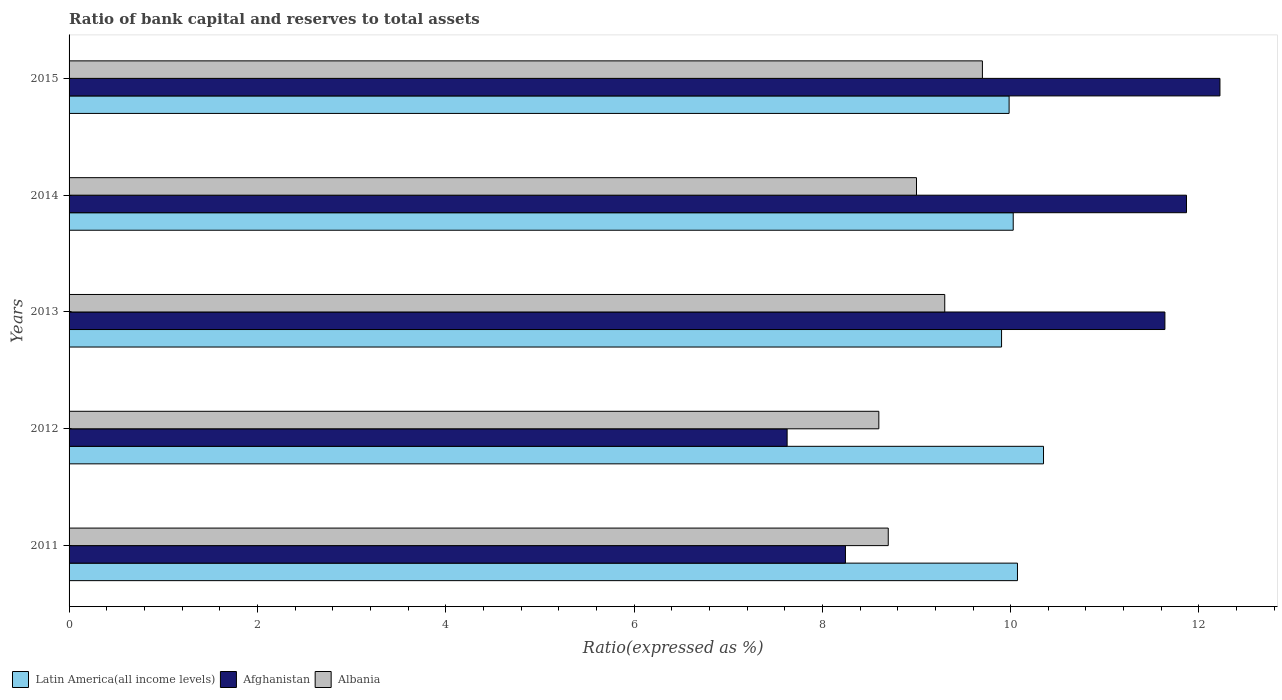How many different coloured bars are there?
Your answer should be very brief. 3. Are the number of bars on each tick of the Y-axis equal?
Ensure brevity in your answer.  Yes. How many bars are there on the 4th tick from the bottom?
Provide a succinct answer. 3. What is the label of the 1st group of bars from the top?
Give a very brief answer. 2015. In how many cases, is the number of bars for a given year not equal to the number of legend labels?
Ensure brevity in your answer.  0. What is the ratio of bank capital and reserves to total assets in Afghanistan in 2013?
Make the answer very short. 11.64. Across all years, what is the maximum ratio of bank capital and reserves to total assets in Albania?
Your response must be concise. 9.7. Across all years, what is the minimum ratio of bank capital and reserves to total assets in Albania?
Keep it short and to the point. 8.6. In which year was the ratio of bank capital and reserves to total assets in Afghanistan maximum?
Ensure brevity in your answer.  2015. What is the total ratio of bank capital and reserves to total assets in Albania in the graph?
Ensure brevity in your answer.  45.3. What is the difference between the ratio of bank capital and reserves to total assets in Afghanistan in 2013 and that in 2014?
Offer a very short reply. -0.23. What is the difference between the ratio of bank capital and reserves to total assets in Afghanistan in 2015 and the ratio of bank capital and reserves to total assets in Albania in 2012?
Give a very brief answer. 3.62. What is the average ratio of bank capital and reserves to total assets in Latin America(all income levels) per year?
Provide a short and direct response. 10.07. In the year 2015, what is the difference between the ratio of bank capital and reserves to total assets in Afghanistan and ratio of bank capital and reserves to total assets in Latin America(all income levels)?
Keep it short and to the point. 2.24. In how many years, is the ratio of bank capital and reserves to total assets in Latin America(all income levels) greater than 1.2000000000000002 %?
Keep it short and to the point. 5. What is the ratio of the ratio of bank capital and reserves to total assets in Albania in 2012 to that in 2014?
Your answer should be compact. 0.96. What is the difference between the highest and the second highest ratio of bank capital and reserves to total assets in Latin America(all income levels)?
Make the answer very short. 0.28. What is the difference between the highest and the lowest ratio of bank capital and reserves to total assets in Albania?
Provide a short and direct response. 1.1. In how many years, is the ratio of bank capital and reserves to total assets in Albania greater than the average ratio of bank capital and reserves to total assets in Albania taken over all years?
Ensure brevity in your answer.  2. Is the sum of the ratio of bank capital and reserves to total assets in Albania in 2013 and 2014 greater than the maximum ratio of bank capital and reserves to total assets in Afghanistan across all years?
Ensure brevity in your answer.  Yes. What does the 1st bar from the top in 2015 represents?
Make the answer very short. Albania. What does the 1st bar from the bottom in 2013 represents?
Make the answer very short. Latin America(all income levels). Are all the bars in the graph horizontal?
Offer a very short reply. Yes. How are the legend labels stacked?
Make the answer very short. Horizontal. What is the title of the graph?
Your answer should be compact. Ratio of bank capital and reserves to total assets. What is the label or title of the X-axis?
Make the answer very short. Ratio(expressed as %). What is the label or title of the Y-axis?
Offer a terse response. Years. What is the Ratio(expressed as %) of Latin America(all income levels) in 2011?
Ensure brevity in your answer.  10.07. What is the Ratio(expressed as %) of Afghanistan in 2011?
Provide a succinct answer. 8.25. What is the Ratio(expressed as %) of Albania in 2011?
Your response must be concise. 8.7. What is the Ratio(expressed as %) of Latin America(all income levels) in 2012?
Give a very brief answer. 10.35. What is the Ratio(expressed as %) of Afghanistan in 2012?
Offer a very short reply. 7.63. What is the Ratio(expressed as %) of Latin America(all income levels) in 2013?
Offer a very short reply. 9.9. What is the Ratio(expressed as %) of Afghanistan in 2013?
Your response must be concise. 11.64. What is the Ratio(expressed as %) in Albania in 2013?
Your answer should be compact. 9.3. What is the Ratio(expressed as %) in Latin America(all income levels) in 2014?
Offer a very short reply. 10.03. What is the Ratio(expressed as %) in Afghanistan in 2014?
Give a very brief answer. 11.87. What is the Ratio(expressed as %) of Albania in 2014?
Provide a short and direct response. 9. What is the Ratio(expressed as %) in Latin America(all income levels) in 2015?
Your response must be concise. 9.98. What is the Ratio(expressed as %) of Afghanistan in 2015?
Provide a short and direct response. 12.22. What is the Ratio(expressed as %) in Albania in 2015?
Provide a short and direct response. 9.7. Across all years, what is the maximum Ratio(expressed as %) of Latin America(all income levels)?
Make the answer very short. 10.35. Across all years, what is the maximum Ratio(expressed as %) in Afghanistan?
Offer a terse response. 12.22. Across all years, what is the minimum Ratio(expressed as %) of Latin America(all income levels)?
Give a very brief answer. 9.9. Across all years, what is the minimum Ratio(expressed as %) in Afghanistan?
Your answer should be compact. 7.63. What is the total Ratio(expressed as %) of Latin America(all income levels) in the graph?
Your answer should be compact. 50.34. What is the total Ratio(expressed as %) in Afghanistan in the graph?
Give a very brief answer. 51.6. What is the total Ratio(expressed as %) of Albania in the graph?
Your response must be concise. 45.3. What is the difference between the Ratio(expressed as %) in Latin America(all income levels) in 2011 and that in 2012?
Provide a succinct answer. -0.28. What is the difference between the Ratio(expressed as %) of Afghanistan in 2011 and that in 2012?
Ensure brevity in your answer.  0.62. What is the difference between the Ratio(expressed as %) of Latin America(all income levels) in 2011 and that in 2013?
Your response must be concise. 0.17. What is the difference between the Ratio(expressed as %) in Afghanistan in 2011 and that in 2013?
Your answer should be very brief. -3.39. What is the difference between the Ratio(expressed as %) in Latin America(all income levels) in 2011 and that in 2014?
Your answer should be compact. 0.05. What is the difference between the Ratio(expressed as %) of Afghanistan in 2011 and that in 2014?
Give a very brief answer. -3.62. What is the difference between the Ratio(expressed as %) of Latin America(all income levels) in 2011 and that in 2015?
Provide a short and direct response. 0.09. What is the difference between the Ratio(expressed as %) of Afghanistan in 2011 and that in 2015?
Offer a very short reply. -3.98. What is the difference between the Ratio(expressed as %) in Albania in 2011 and that in 2015?
Provide a short and direct response. -1. What is the difference between the Ratio(expressed as %) in Latin America(all income levels) in 2012 and that in 2013?
Offer a very short reply. 0.45. What is the difference between the Ratio(expressed as %) of Afghanistan in 2012 and that in 2013?
Provide a short and direct response. -4.01. What is the difference between the Ratio(expressed as %) in Latin America(all income levels) in 2012 and that in 2014?
Provide a short and direct response. 0.32. What is the difference between the Ratio(expressed as %) of Afghanistan in 2012 and that in 2014?
Your response must be concise. -4.24. What is the difference between the Ratio(expressed as %) of Albania in 2012 and that in 2014?
Ensure brevity in your answer.  -0.4. What is the difference between the Ratio(expressed as %) in Latin America(all income levels) in 2012 and that in 2015?
Ensure brevity in your answer.  0.37. What is the difference between the Ratio(expressed as %) of Afghanistan in 2012 and that in 2015?
Provide a short and direct response. -4.6. What is the difference between the Ratio(expressed as %) of Latin America(all income levels) in 2013 and that in 2014?
Your answer should be compact. -0.12. What is the difference between the Ratio(expressed as %) in Afghanistan in 2013 and that in 2014?
Keep it short and to the point. -0.23. What is the difference between the Ratio(expressed as %) of Latin America(all income levels) in 2013 and that in 2015?
Provide a succinct answer. -0.08. What is the difference between the Ratio(expressed as %) of Afghanistan in 2013 and that in 2015?
Provide a succinct answer. -0.58. What is the difference between the Ratio(expressed as %) of Latin America(all income levels) in 2014 and that in 2015?
Make the answer very short. 0.04. What is the difference between the Ratio(expressed as %) of Afghanistan in 2014 and that in 2015?
Provide a succinct answer. -0.36. What is the difference between the Ratio(expressed as %) in Latin America(all income levels) in 2011 and the Ratio(expressed as %) in Afghanistan in 2012?
Keep it short and to the point. 2.45. What is the difference between the Ratio(expressed as %) in Latin America(all income levels) in 2011 and the Ratio(expressed as %) in Albania in 2012?
Ensure brevity in your answer.  1.47. What is the difference between the Ratio(expressed as %) of Afghanistan in 2011 and the Ratio(expressed as %) of Albania in 2012?
Your answer should be very brief. -0.35. What is the difference between the Ratio(expressed as %) of Latin America(all income levels) in 2011 and the Ratio(expressed as %) of Afghanistan in 2013?
Provide a succinct answer. -1.57. What is the difference between the Ratio(expressed as %) in Latin America(all income levels) in 2011 and the Ratio(expressed as %) in Albania in 2013?
Your answer should be very brief. 0.77. What is the difference between the Ratio(expressed as %) of Afghanistan in 2011 and the Ratio(expressed as %) of Albania in 2013?
Offer a very short reply. -1.05. What is the difference between the Ratio(expressed as %) in Latin America(all income levels) in 2011 and the Ratio(expressed as %) in Afghanistan in 2014?
Keep it short and to the point. -1.8. What is the difference between the Ratio(expressed as %) of Latin America(all income levels) in 2011 and the Ratio(expressed as %) of Albania in 2014?
Provide a short and direct response. 1.07. What is the difference between the Ratio(expressed as %) in Afghanistan in 2011 and the Ratio(expressed as %) in Albania in 2014?
Your response must be concise. -0.75. What is the difference between the Ratio(expressed as %) in Latin America(all income levels) in 2011 and the Ratio(expressed as %) in Afghanistan in 2015?
Offer a very short reply. -2.15. What is the difference between the Ratio(expressed as %) in Latin America(all income levels) in 2011 and the Ratio(expressed as %) in Albania in 2015?
Your response must be concise. 0.37. What is the difference between the Ratio(expressed as %) of Afghanistan in 2011 and the Ratio(expressed as %) of Albania in 2015?
Provide a short and direct response. -1.45. What is the difference between the Ratio(expressed as %) in Latin America(all income levels) in 2012 and the Ratio(expressed as %) in Afghanistan in 2013?
Offer a terse response. -1.29. What is the difference between the Ratio(expressed as %) in Latin America(all income levels) in 2012 and the Ratio(expressed as %) in Albania in 2013?
Provide a succinct answer. 1.05. What is the difference between the Ratio(expressed as %) in Afghanistan in 2012 and the Ratio(expressed as %) in Albania in 2013?
Keep it short and to the point. -1.67. What is the difference between the Ratio(expressed as %) in Latin America(all income levels) in 2012 and the Ratio(expressed as %) in Afghanistan in 2014?
Ensure brevity in your answer.  -1.52. What is the difference between the Ratio(expressed as %) in Latin America(all income levels) in 2012 and the Ratio(expressed as %) in Albania in 2014?
Offer a very short reply. 1.35. What is the difference between the Ratio(expressed as %) in Afghanistan in 2012 and the Ratio(expressed as %) in Albania in 2014?
Offer a very short reply. -1.37. What is the difference between the Ratio(expressed as %) of Latin America(all income levels) in 2012 and the Ratio(expressed as %) of Afghanistan in 2015?
Your answer should be very brief. -1.87. What is the difference between the Ratio(expressed as %) of Latin America(all income levels) in 2012 and the Ratio(expressed as %) of Albania in 2015?
Keep it short and to the point. 0.65. What is the difference between the Ratio(expressed as %) in Afghanistan in 2012 and the Ratio(expressed as %) in Albania in 2015?
Provide a succinct answer. -2.07. What is the difference between the Ratio(expressed as %) in Latin America(all income levels) in 2013 and the Ratio(expressed as %) in Afghanistan in 2014?
Provide a succinct answer. -1.96. What is the difference between the Ratio(expressed as %) of Latin America(all income levels) in 2013 and the Ratio(expressed as %) of Albania in 2014?
Make the answer very short. 0.9. What is the difference between the Ratio(expressed as %) in Afghanistan in 2013 and the Ratio(expressed as %) in Albania in 2014?
Offer a terse response. 2.64. What is the difference between the Ratio(expressed as %) of Latin America(all income levels) in 2013 and the Ratio(expressed as %) of Afghanistan in 2015?
Keep it short and to the point. -2.32. What is the difference between the Ratio(expressed as %) of Latin America(all income levels) in 2013 and the Ratio(expressed as %) of Albania in 2015?
Your response must be concise. 0.2. What is the difference between the Ratio(expressed as %) in Afghanistan in 2013 and the Ratio(expressed as %) in Albania in 2015?
Give a very brief answer. 1.94. What is the difference between the Ratio(expressed as %) of Latin America(all income levels) in 2014 and the Ratio(expressed as %) of Afghanistan in 2015?
Your answer should be very brief. -2.2. What is the difference between the Ratio(expressed as %) in Latin America(all income levels) in 2014 and the Ratio(expressed as %) in Albania in 2015?
Provide a short and direct response. 0.33. What is the difference between the Ratio(expressed as %) in Afghanistan in 2014 and the Ratio(expressed as %) in Albania in 2015?
Keep it short and to the point. 2.17. What is the average Ratio(expressed as %) of Latin America(all income levels) per year?
Ensure brevity in your answer.  10.07. What is the average Ratio(expressed as %) in Afghanistan per year?
Provide a succinct answer. 10.32. What is the average Ratio(expressed as %) in Albania per year?
Provide a succinct answer. 9.06. In the year 2011, what is the difference between the Ratio(expressed as %) in Latin America(all income levels) and Ratio(expressed as %) in Afghanistan?
Keep it short and to the point. 1.83. In the year 2011, what is the difference between the Ratio(expressed as %) in Latin America(all income levels) and Ratio(expressed as %) in Albania?
Make the answer very short. 1.37. In the year 2011, what is the difference between the Ratio(expressed as %) of Afghanistan and Ratio(expressed as %) of Albania?
Provide a succinct answer. -0.45. In the year 2012, what is the difference between the Ratio(expressed as %) of Latin America(all income levels) and Ratio(expressed as %) of Afghanistan?
Provide a succinct answer. 2.72. In the year 2012, what is the difference between the Ratio(expressed as %) of Latin America(all income levels) and Ratio(expressed as %) of Albania?
Provide a short and direct response. 1.75. In the year 2012, what is the difference between the Ratio(expressed as %) in Afghanistan and Ratio(expressed as %) in Albania?
Your answer should be compact. -0.97. In the year 2013, what is the difference between the Ratio(expressed as %) in Latin America(all income levels) and Ratio(expressed as %) in Afghanistan?
Make the answer very short. -1.73. In the year 2013, what is the difference between the Ratio(expressed as %) in Latin America(all income levels) and Ratio(expressed as %) in Albania?
Keep it short and to the point. 0.6. In the year 2013, what is the difference between the Ratio(expressed as %) in Afghanistan and Ratio(expressed as %) in Albania?
Offer a very short reply. 2.34. In the year 2014, what is the difference between the Ratio(expressed as %) in Latin America(all income levels) and Ratio(expressed as %) in Afghanistan?
Offer a very short reply. -1.84. In the year 2014, what is the difference between the Ratio(expressed as %) of Latin America(all income levels) and Ratio(expressed as %) of Albania?
Provide a succinct answer. 1.03. In the year 2014, what is the difference between the Ratio(expressed as %) of Afghanistan and Ratio(expressed as %) of Albania?
Make the answer very short. 2.87. In the year 2015, what is the difference between the Ratio(expressed as %) in Latin America(all income levels) and Ratio(expressed as %) in Afghanistan?
Give a very brief answer. -2.24. In the year 2015, what is the difference between the Ratio(expressed as %) in Latin America(all income levels) and Ratio(expressed as %) in Albania?
Provide a short and direct response. 0.28. In the year 2015, what is the difference between the Ratio(expressed as %) of Afghanistan and Ratio(expressed as %) of Albania?
Make the answer very short. 2.52. What is the ratio of the Ratio(expressed as %) of Latin America(all income levels) in 2011 to that in 2012?
Keep it short and to the point. 0.97. What is the ratio of the Ratio(expressed as %) of Afghanistan in 2011 to that in 2012?
Offer a terse response. 1.08. What is the ratio of the Ratio(expressed as %) of Albania in 2011 to that in 2012?
Your answer should be very brief. 1.01. What is the ratio of the Ratio(expressed as %) in Latin America(all income levels) in 2011 to that in 2013?
Provide a succinct answer. 1.02. What is the ratio of the Ratio(expressed as %) of Afghanistan in 2011 to that in 2013?
Your answer should be very brief. 0.71. What is the ratio of the Ratio(expressed as %) of Albania in 2011 to that in 2013?
Ensure brevity in your answer.  0.94. What is the ratio of the Ratio(expressed as %) of Afghanistan in 2011 to that in 2014?
Your response must be concise. 0.69. What is the ratio of the Ratio(expressed as %) of Albania in 2011 to that in 2014?
Provide a succinct answer. 0.97. What is the ratio of the Ratio(expressed as %) in Latin America(all income levels) in 2011 to that in 2015?
Your response must be concise. 1.01. What is the ratio of the Ratio(expressed as %) of Afghanistan in 2011 to that in 2015?
Your answer should be very brief. 0.67. What is the ratio of the Ratio(expressed as %) in Albania in 2011 to that in 2015?
Your response must be concise. 0.9. What is the ratio of the Ratio(expressed as %) in Latin America(all income levels) in 2012 to that in 2013?
Provide a short and direct response. 1.04. What is the ratio of the Ratio(expressed as %) of Afghanistan in 2012 to that in 2013?
Give a very brief answer. 0.66. What is the ratio of the Ratio(expressed as %) of Albania in 2012 to that in 2013?
Your response must be concise. 0.92. What is the ratio of the Ratio(expressed as %) in Latin America(all income levels) in 2012 to that in 2014?
Offer a terse response. 1.03. What is the ratio of the Ratio(expressed as %) in Afghanistan in 2012 to that in 2014?
Offer a terse response. 0.64. What is the ratio of the Ratio(expressed as %) in Albania in 2012 to that in 2014?
Your answer should be compact. 0.96. What is the ratio of the Ratio(expressed as %) in Latin America(all income levels) in 2012 to that in 2015?
Offer a terse response. 1.04. What is the ratio of the Ratio(expressed as %) in Afghanistan in 2012 to that in 2015?
Ensure brevity in your answer.  0.62. What is the ratio of the Ratio(expressed as %) in Albania in 2012 to that in 2015?
Make the answer very short. 0.89. What is the ratio of the Ratio(expressed as %) in Afghanistan in 2013 to that in 2014?
Keep it short and to the point. 0.98. What is the ratio of the Ratio(expressed as %) in Albania in 2013 to that in 2014?
Provide a short and direct response. 1.03. What is the ratio of the Ratio(expressed as %) of Afghanistan in 2013 to that in 2015?
Offer a very short reply. 0.95. What is the ratio of the Ratio(expressed as %) of Albania in 2013 to that in 2015?
Offer a terse response. 0.96. What is the ratio of the Ratio(expressed as %) in Latin America(all income levels) in 2014 to that in 2015?
Your response must be concise. 1. What is the ratio of the Ratio(expressed as %) of Afghanistan in 2014 to that in 2015?
Your response must be concise. 0.97. What is the ratio of the Ratio(expressed as %) in Albania in 2014 to that in 2015?
Offer a terse response. 0.93. What is the difference between the highest and the second highest Ratio(expressed as %) of Latin America(all income levels)?
Your answer should be compact. 0.28. What is the difference between the highest and the second highest Ratio(expressed as %) of Afghanistan?
Provide a short and direct response. 0.36. What is the difference between the highest and the lowest Ratio(expressed as %) of Latin America(all income levels)?
Give a very brief answer. 0.45. What is the difference between the highest and the lowest Ratio(expressed as %) in Afghanistan?
Your answer should be compact. 4.6. 